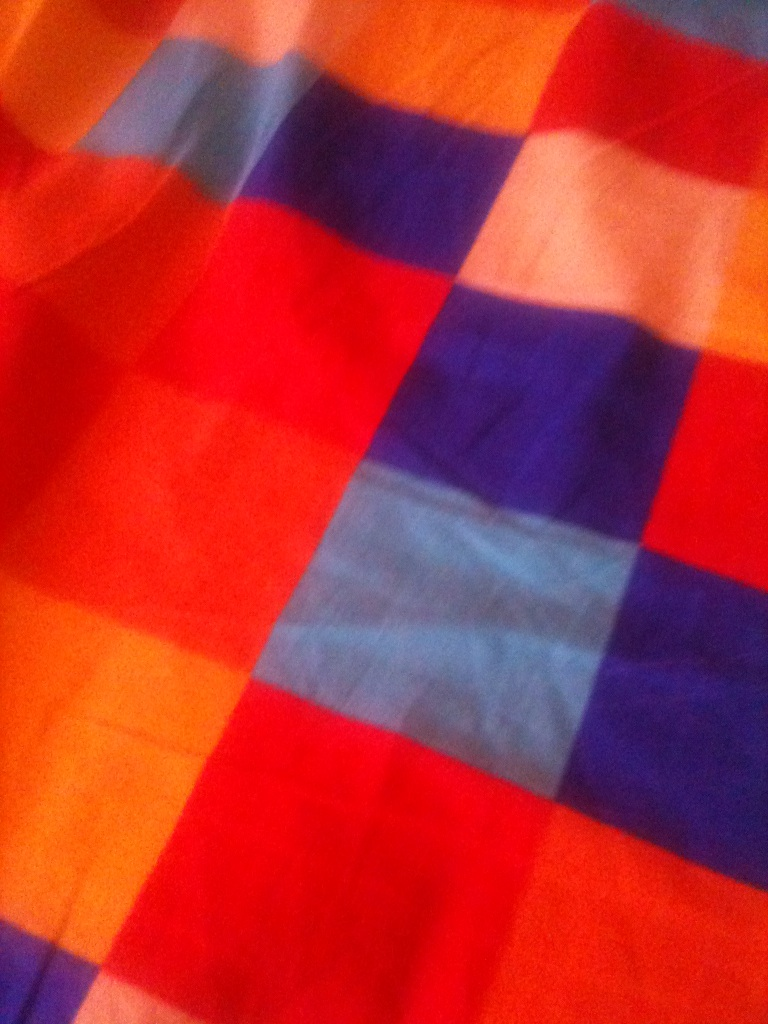Imagine you could shrink down and explore the fabric pattern. What would you see? If I could shrink down to explore the fabric pattern, it would be like wandering through a colorful, wonderous landscape. The vibrant squares of red, blue, orange, and pink would tower over me like giant, shimmering walls, creating a maze-like environment. The texture of the fabric, with its smooth and gentle weave, would resemble expansive fields, where each thread might appear as wide as a river, weaving its own path through the landscape. The slight variations in color and shading would create gentle hills and valleys, inviting exploration and discovery around every corner. 